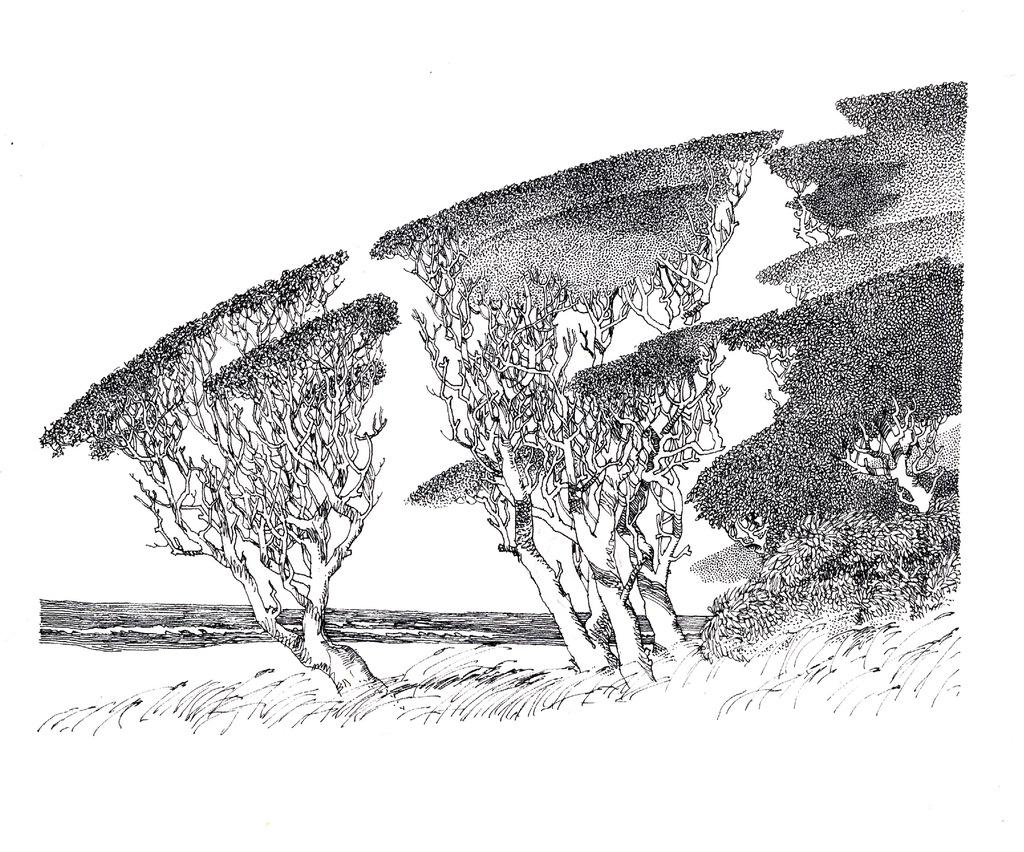What is depicted in the center of the image? There is a sketch of trees and water in the center of the image. Can you describe the sketch of trees? The sketch of trees is in the center of the image. What else is featured in the sketch in the center of the image? There is also a sketch of water in the center of the image. How many seeds can be seen in the sketch of trees? There are no seeds visible in the sketch of trees; it is a drawing of trees and water. What type of afterthought is depicted in the sketch of water? There is no afterthought depicted in the sketch of water; it is a drawing of trees and water. 